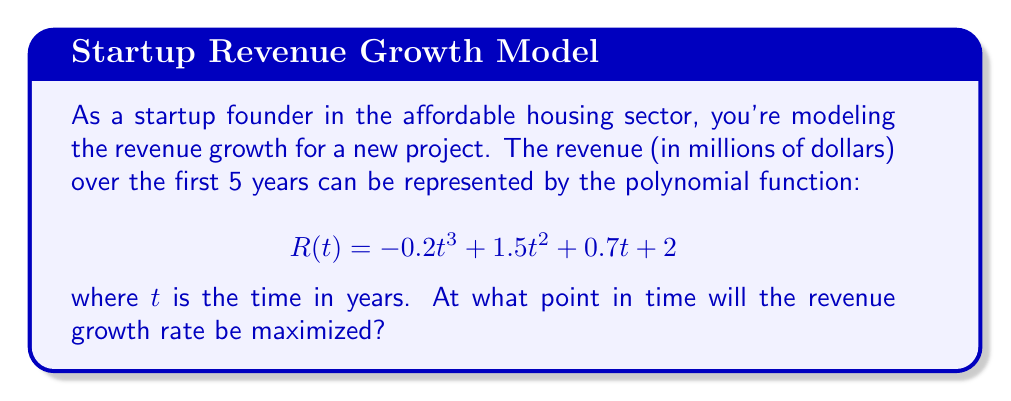Can you answer this question? To find the point where revenue growth rate is maximized, we need to follow these steps:

1) The revenue growth rate is represented by the first derivative of the revenue function. Let's call this $R'(t)$.

2) Calculate $R'(t)$:
   $$R'(t) = -0.6t^2 + 3t + 0.7$$

3) The maximum growth rate will occur at the point where the second derivative equals zero. So we need to find $R''(t)$ and set it to zero.

4) Calculate $R''(t)$:
   $$R''(t) = -1.2t + 3$$

5) Set $R''(t) = 0$ and solve for $t$:
   $$-1.2t + 3 = 0$$
   $$-1.2t = -3$$
   $$t = 2.5$$

6) To confirm this is a maximum (not a minimum), we can check that $R'''(t) < 0$:
   $$R'''(t) = -1.2$$
   Since this is negative, we confirm that $t = 2.5$ gives us a maximum.

Therefore, the revenue growth rate will be maximized at $t = 2.5$ years.
Answer: 2.5 years 